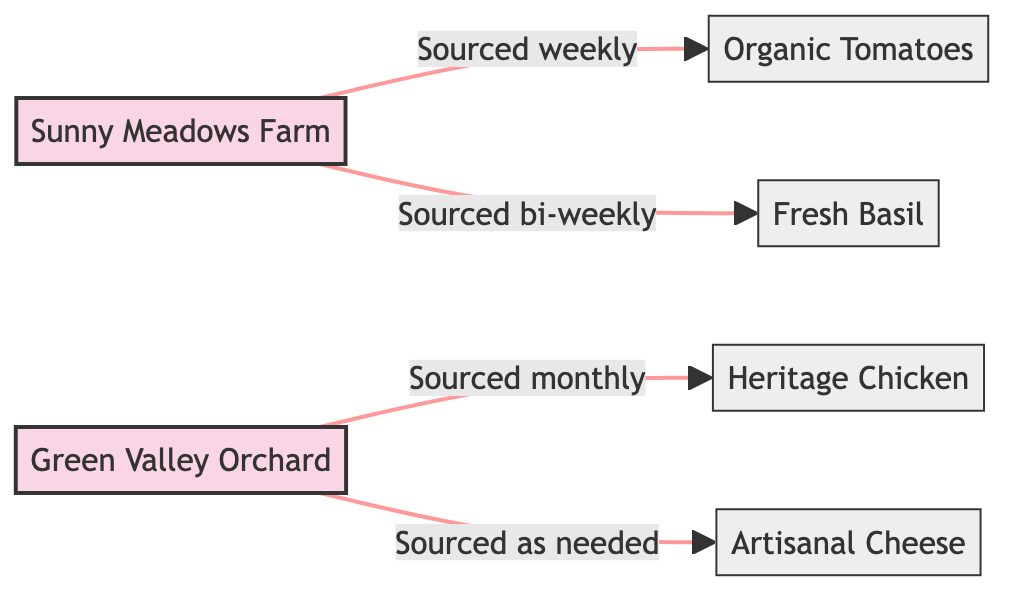What suppliers source Organic Tomatoes? The edge connected to Organic Tomatoes indicates that Sunny Meadows Farm is the supplier sourcing this ingredient.
Answer: Sunny Meadows Farm How often are Fresh Basil sourced? The label on the edge connecting Sunny Meadows Farm to Fresh Basil indicates the sourcing frequency is bi-weekly.
Answer: Bi-weekly How many ingredients are provided by Green Valley Orchard? There are two edges emanating from Green Valley Orchard, each leading to an ingredient: Heritage Chicken and Artisanal Cheese, indicating that it provides two ingredients.
Answer: 2 Which ingredient is sourced as needed? The edge from Green Valley Orchard to Artisanal Cheese indicates that this ingredient is sourced as needed.
Answer: Artisanal Cheese What is the sourcing frequency for Heritage Chicken? The edge connecting Green Valley Orchard to Heritage Chicken states that this ingredient is sourced monthly.
Answer: Monthly Which supplier sources ingredients weekly? Looking at the edges connected to ingredients sourced weekly, we can see that only Sunny Meadows Farm is sourcing ingredients on a weekly basis.
Answer: Sunny Meadows Farm What type of graph does this diagram represent? The relationships and the direction of sourcing from suppliers to ingredients indicate that this is a directed graph, as it has nodes and directed edges.
Answer: Directed graph Which ingredient is sourced monthly? The edge from Green Valley Orchard to Heritage Chicken specifies that this ingredient is sourced monthly.
Answer: Heritage Chicken How many edges are in the diagram? The diagram consists of four edges, each representing a unique sourcing relationship from suppliers to ingredients.
Answer: 4 